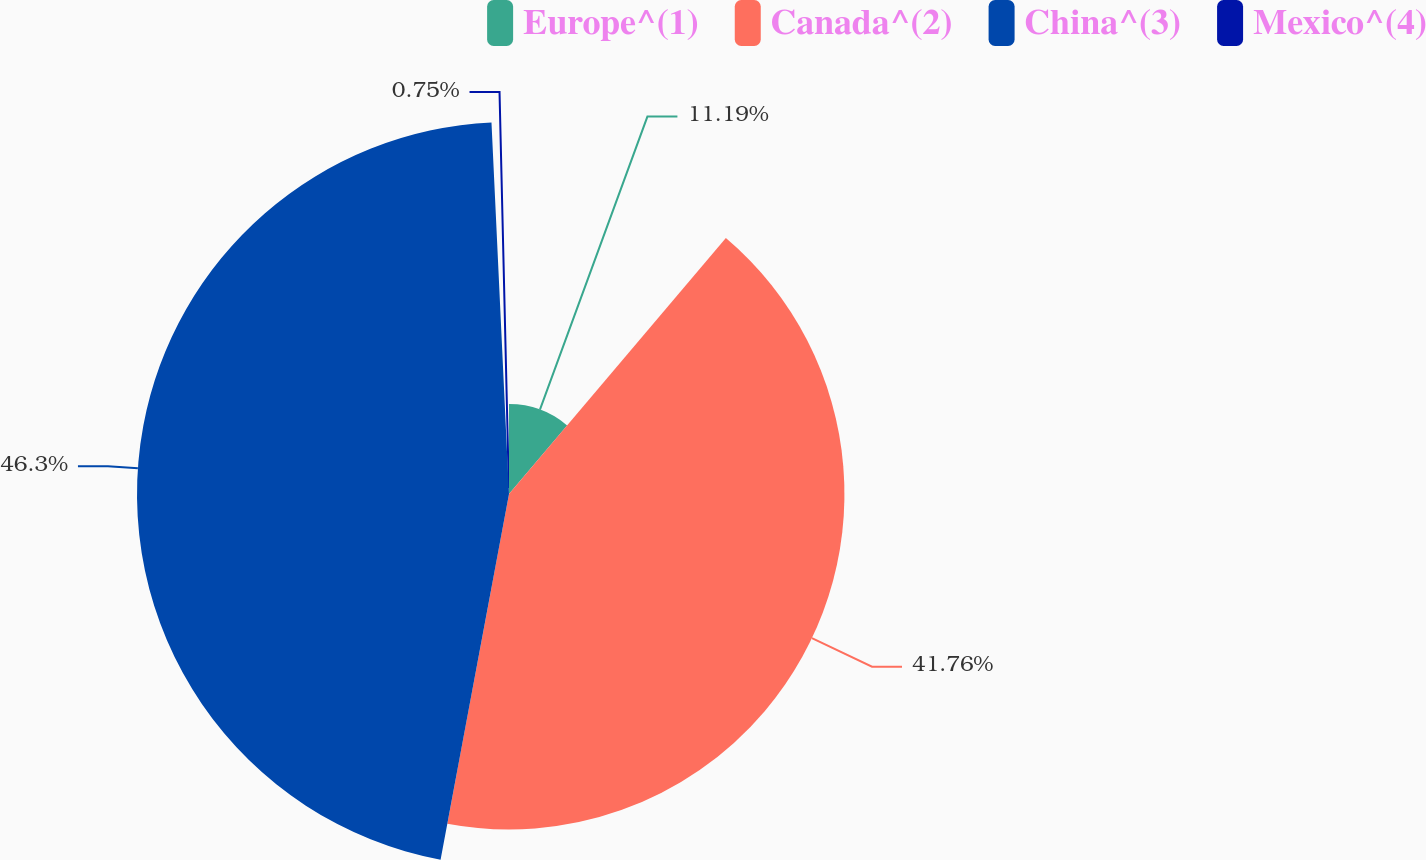Convert chart. <chart><loc_0><loc_0><loc_500><loc_500><pie_chart><fcel>Europe^(1)<fcel>Canada^(2)<fcel>China^(3)<fcel>Mexico^(4)<nl><fcel>11.19%<fcel>41.76%<fcel>46.31%<fcel>0.75%<nl></chart> 